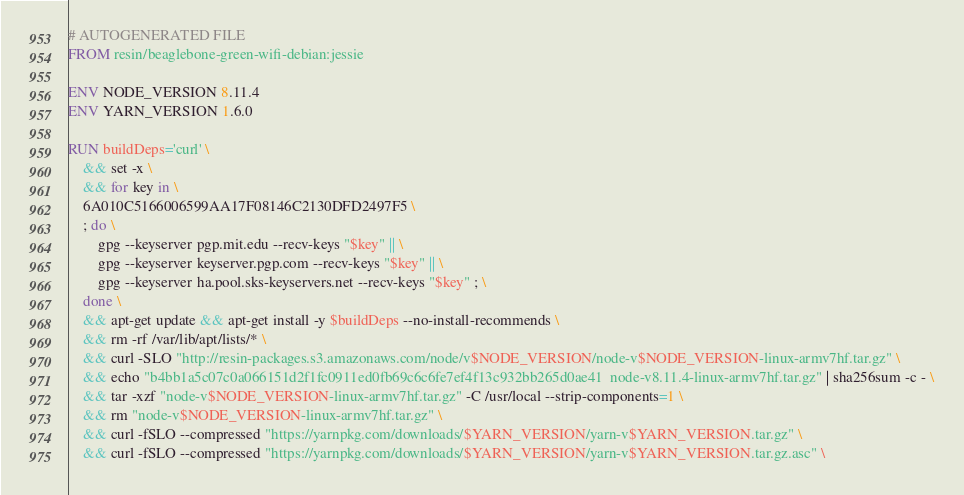Convert code to text. <code><loc_0><loc_0><loc_500><loc_500><_Dockerfile_># AUTOGENERATED FILE
FROM resin/beaglebone-green-wifi-debian:jessie

ENV NODE_VERSION 8.11.4
ENV YARN_VERSION 1.6.0

RUN buildDeps='curl' \
	&& set -x \
	&& for key in \
	6A010C5166006599AA17F08146C2130DFD2497F5 \
	; do \
		gpg --keyserver pgp.mit.edu --recv-keys "$key" || \
		gpg --keyserver keyserver.pgp.com --recv-keys "$key" || \
		gpg --keyserver ha.pool.sks-keyservers.net --recv-keys "$key" ; \
	done \
	&& apt-get update && apt-get install -y $buildDeps --no-install-recommends \
	&& rm -rf /var/lib/apt/lists/* \
	&& curl -SLO "http://resin-packages.s3.amazonaws.com/node/v$NODE_VERSION/node-v$NODE_VERSION-linux-armv7hf.tar.gz" \
	&& echo "b4bb1a5c07c0a066151d2f1fc0911ed0fb69c6c6fe7ef4f13c932bb265d0ae41  node-v8.11.4-linux-armv7hf.tar.gz" | sha256sum -c - \
	&& tar -xzf "node-v$NODE_VERSION-linux-armv7hf.tar.gz" -C /usr/local --strip-components=1 \
	&& rm "node-v$NODE_VERSION-linux-armv7hf.tar.gz" \
	&& curl -fSLO --compressed "https://yarnpkg.com/downloads/$YARN_VERSION/yarn-v$YARN_VERSION.tar.gz" \
	&& curl -fSLO --compressed "https://yarnpkg.com/downloads/$YARN_VERSION/yarn-v$YARN_VERSION.tar.gz.asc" \</code> 